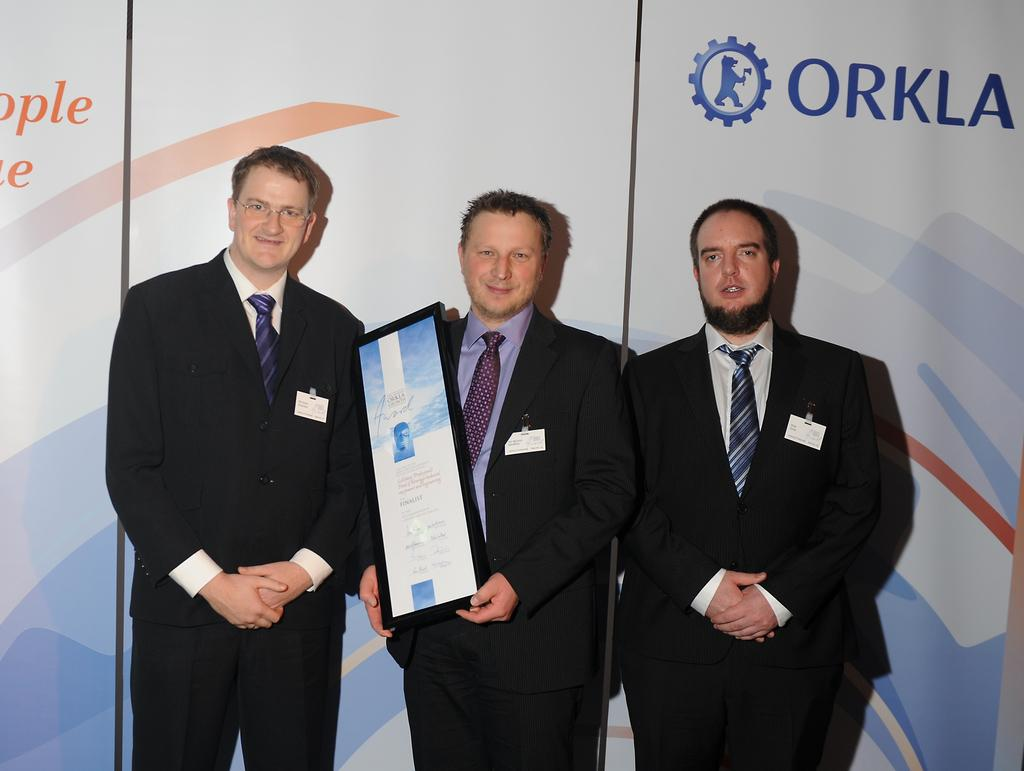How many people are in the image? There are three persons standing in the center of the image. What is one person holding? One person is holding a board. Can you describe the background of the image? There are additional boards visible in the background of the image. What type of copper jewelry is the grandmother wearing in the image? There is no grandmother or copper jewelry present in the image. How many cats can be seen playing with the boards in the image? There are no cats present in the image; it features three persons and additional boards. 